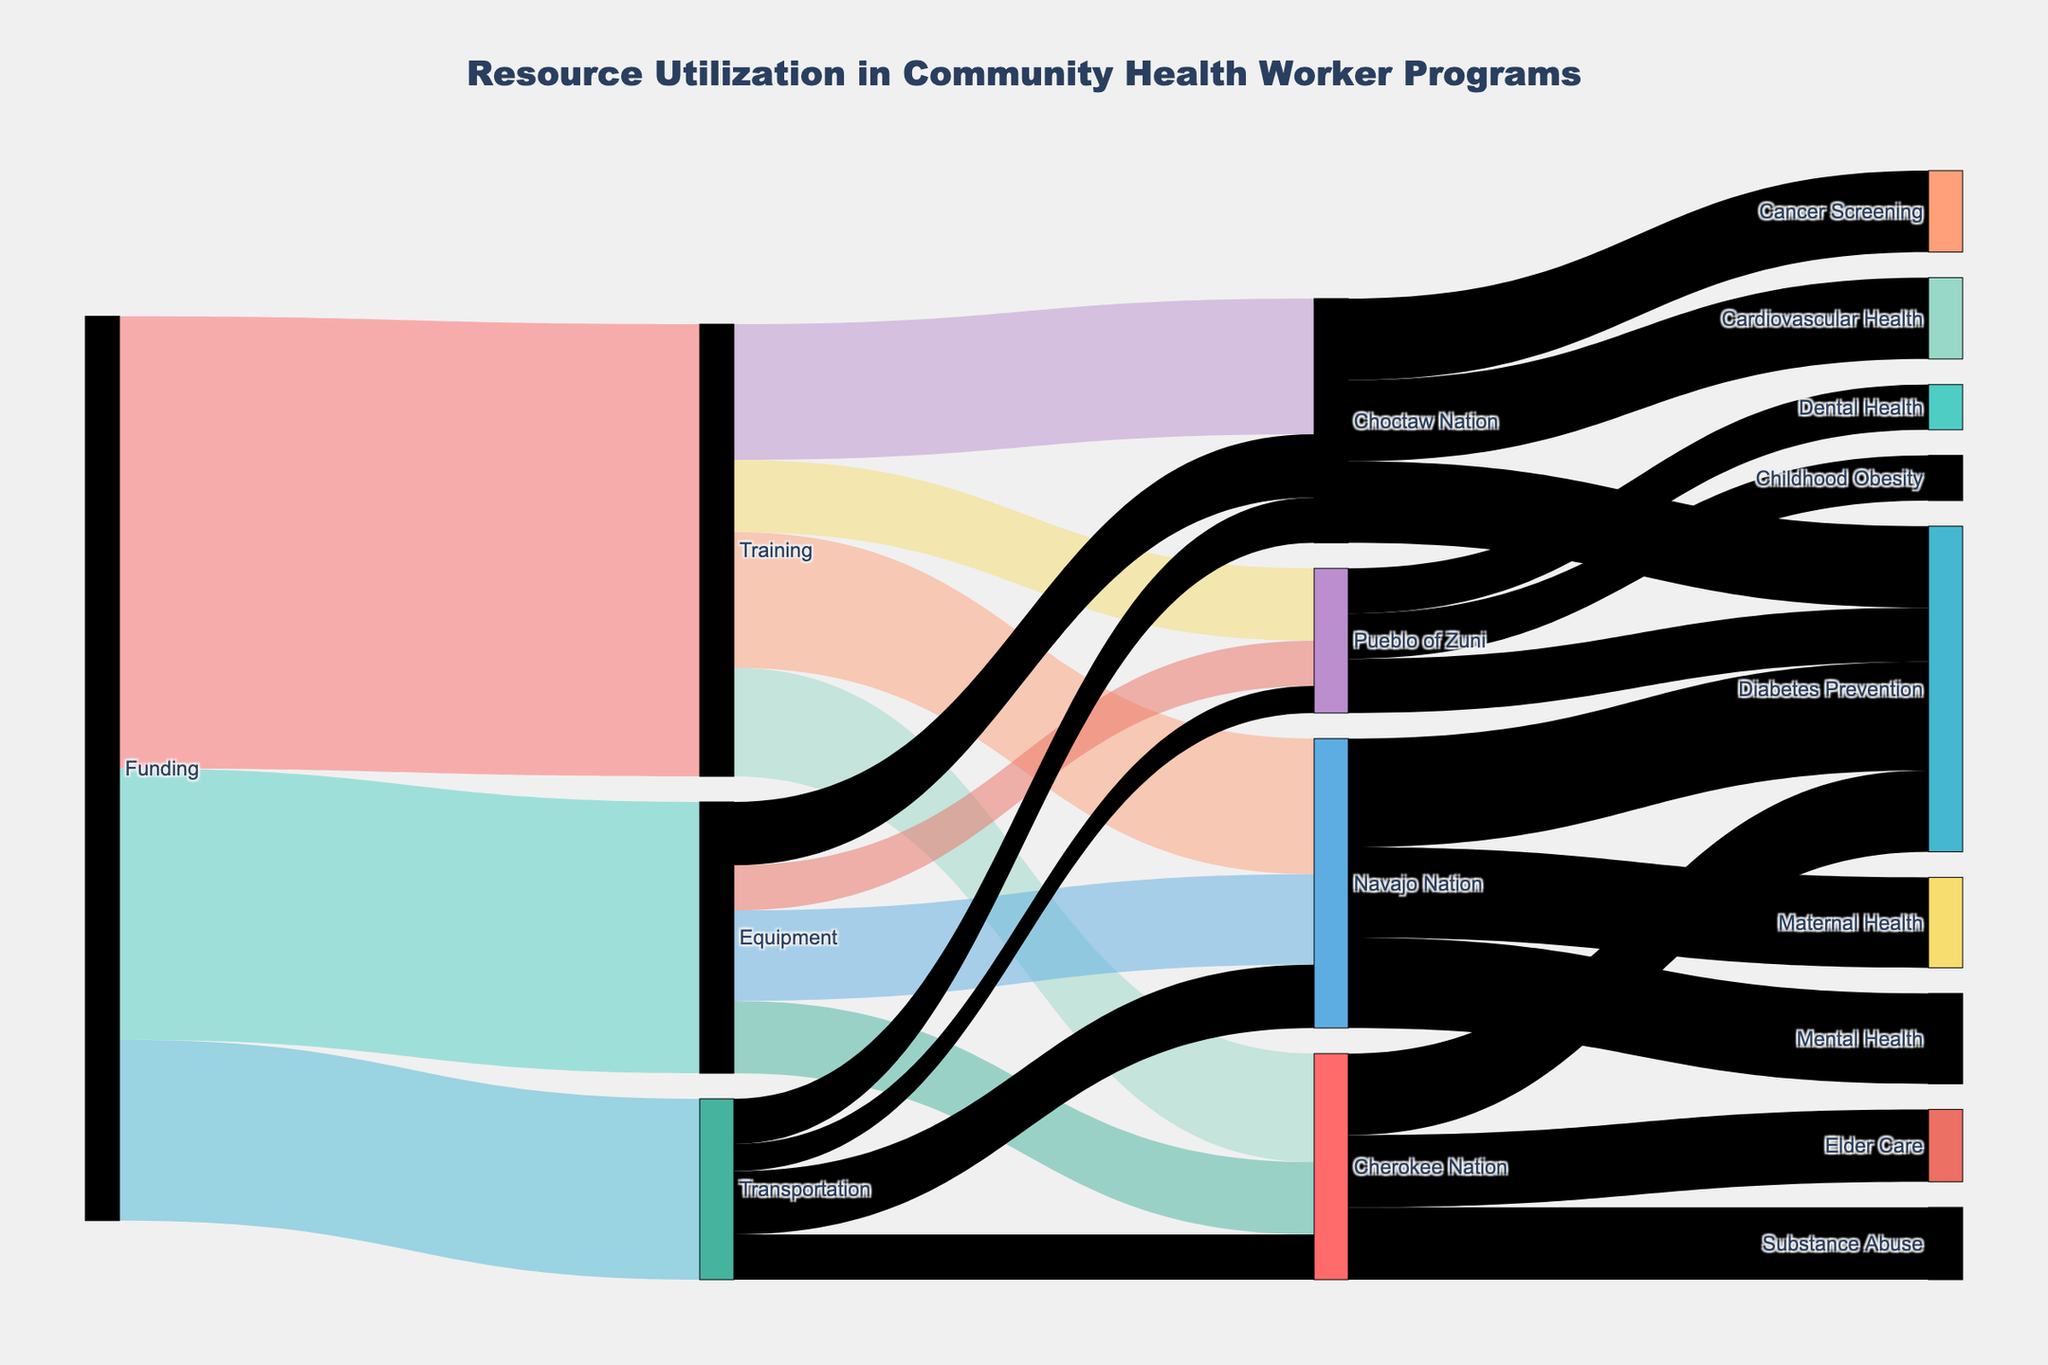What is the main title of the Sankey Diagram? The main title is typically found at the top of the diagram. In this diagram, it is "Resource Utilization in Community Health Worker Programs".
Answer: Resource Utilization in Community Health Worker Programs Which category received the most funding? The categories that received funding are Training, Equipment, and Transportation. By comparing their values, Training received the highest funding of 500,000.
Answer: Training What is the total funding allocated for Equipment and Transportation combined? Adding the funding amounts for Equipment (300,000) and Transportation (200,000) gives the total: 300,000 + 200,000 = 500,000.
Answer: 500,000 How much funding was allocated to Diabetes Prevention across all regions? Adding the funding amounts for Diabetes Prevention in Navajo Nation (120,000), Cherokee Nation (90,000), Pueblo of Zuni (60,000), and Choctaw Nation (90,000) gives the total: 120,000 + 90,000 + 60,000 + 90,000 = 360,000.
Answer: 360,000 Which region received the most funding for Transportation? The transportation funding for each region is: Navajo Nation (70,000), Cherokee Nation (50,000), Pueblo of Zuni (30,000), and Choctaw Nation (50,000). Navajo Nation received the highest amount.
Answer: Navajo Nation Compare the funding values for Maternal Health in Navajo Nation versus Cancer Screening in Choctaw Nation. Which is higher? The funding for Maternal Health in Navajo Nation is 100,000, while Cancer Screening in Choctaw Nation also received 90,000. Maternal Health in Navajo Nation has the higher value.
Answer: Maternal Health in Navajo Nation How much funding did Cherokee Nation receive in total for all health program categories? Summing up the funding directed to Cherokee Nation for Diabetes Prevention (90,000), Substance Abuse (80,000), and Elder Care (80,000) gives: 90,000 + 80,000 + 80,000 = 250,000.
Answer: 250,000 What are the top two health categories funded in Navajo Nation, and their respective funding amounts? The funding amounts for health categories in Navajo Nation are Diabetes Prevention (120,000), Maternal Health (100,000), and Mental Health (100,000). The top two are Diabetes Prevention (120,000) and either Maternal Health or Mental Health (100,000 each).
Answer: Diabetes Prevention 120,000, Maternal Health or Mental Health 100,000 Which region has the most diverse set of health programs? By examining the number of different health programs, Choctaw Nation has three different health programs (Diabetes Prevention, Cardiovascular Health, Cancer Screening), which is the highest among all regions.
Answer: Choctaw Nation 